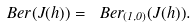Convert formula to latex. <formula><loc_0><loc_0><loc_500><loc_500>\ B e r ( J ( h ) ) = \ B e r _ { ( 1 , 0 ) } ( J ( h ) ) .</formula> 